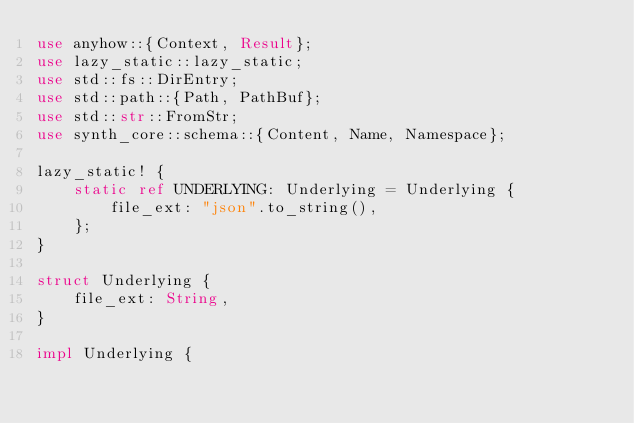Convert code to text. <code><loc_0><loc_0><loc_500><loc_500><_Rust_>use anyhow::{Context, Result};
use lazy_static::lazy_static;
use std::fs::DirEntry;
use std::path::{Path, PathBuf};
use std::str::FromStr;
use synth_core::schema::{Content, Name, Namespace};

lazy_static! {
    static ref UNDERLYING: Underlying = Underlying {
        file_ext: "json".to_string(),
    };
}

struct Underlying {
    file_ext: String,
}

impl Underlying {</code> 